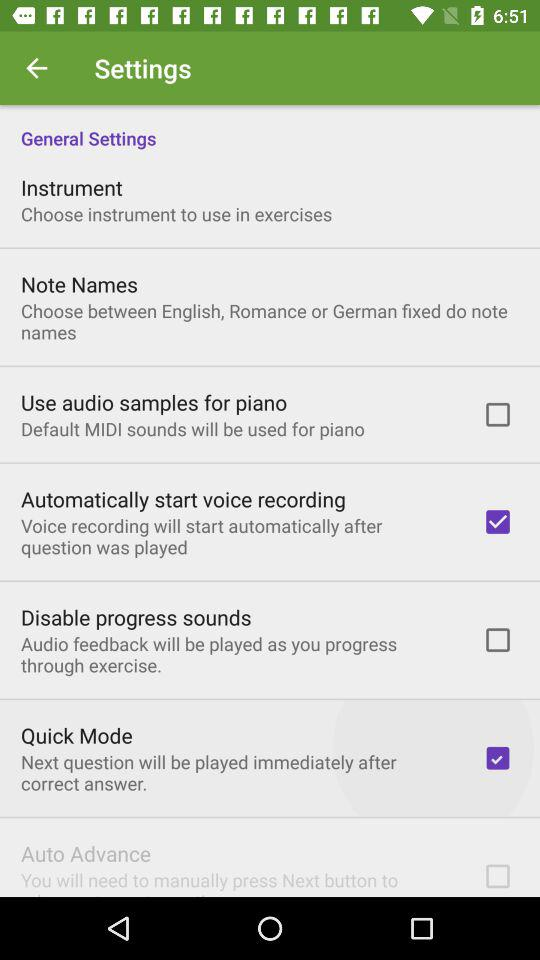What is the status of "Use audio samples for piano"? The status is off. 